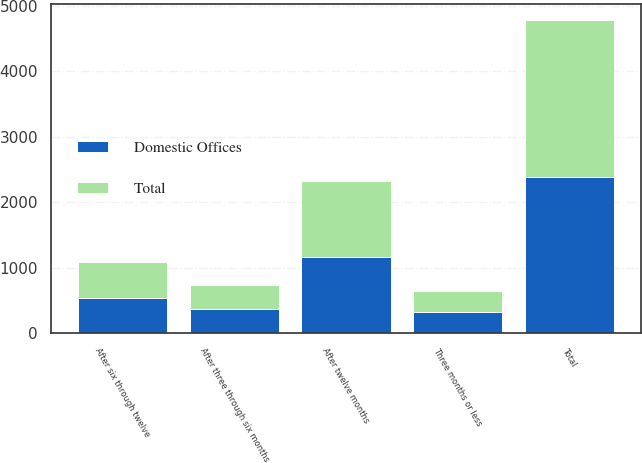<chart> <loc_0><loc_0><loc_500><loc_500><stacked_bar_chart><ecel><fcel>Three months or less<fcel>After three through six months<fcel>After six through twelve<fcel>After twelve months<fcel>Total<nl><fcel>Domestic Offices<fcel>324<fcel>366<fcel>542<fcel>1160<fcel>2392<nl><fcel>Total<fcel>324<fcel>366<fcel>542<fcel>1160<fcel>2392<nl></chart> 